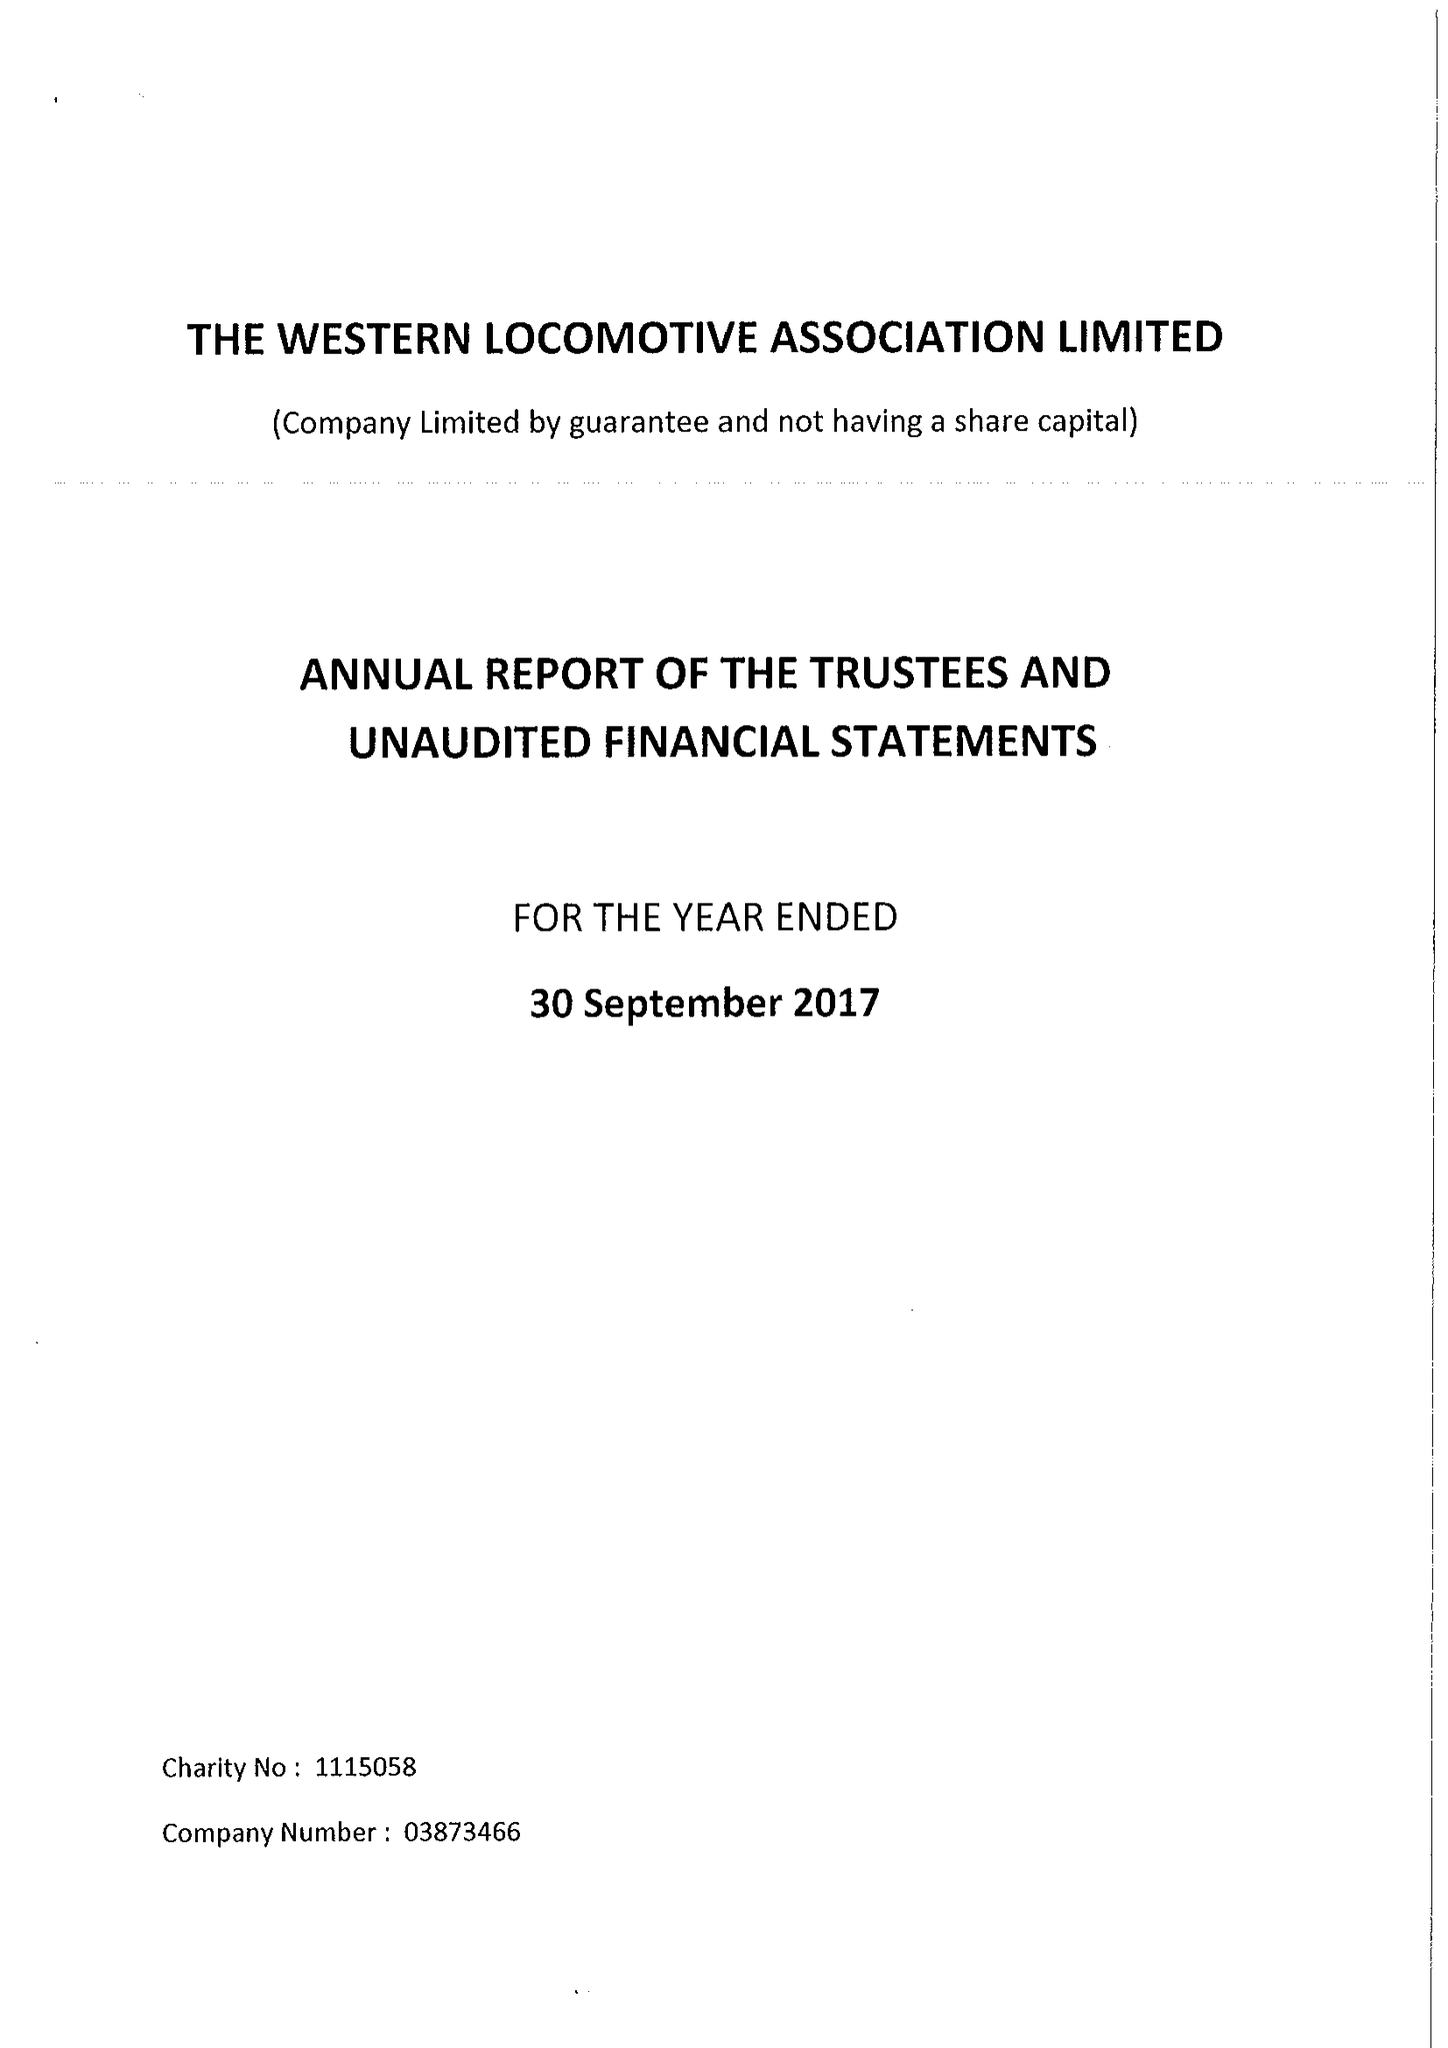What is the value for the report_date?
Answer the question using a single word or phrase. 2017-09-30 